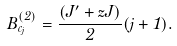<formula> <loc_0><loc_0><loc_500><loc_500>B _ { c _ { j } } ^ { ( 2 ) } = \frac { ( J ^ { \prime } + z J ) } { 2 } ( j + 1 ) .</formula> 